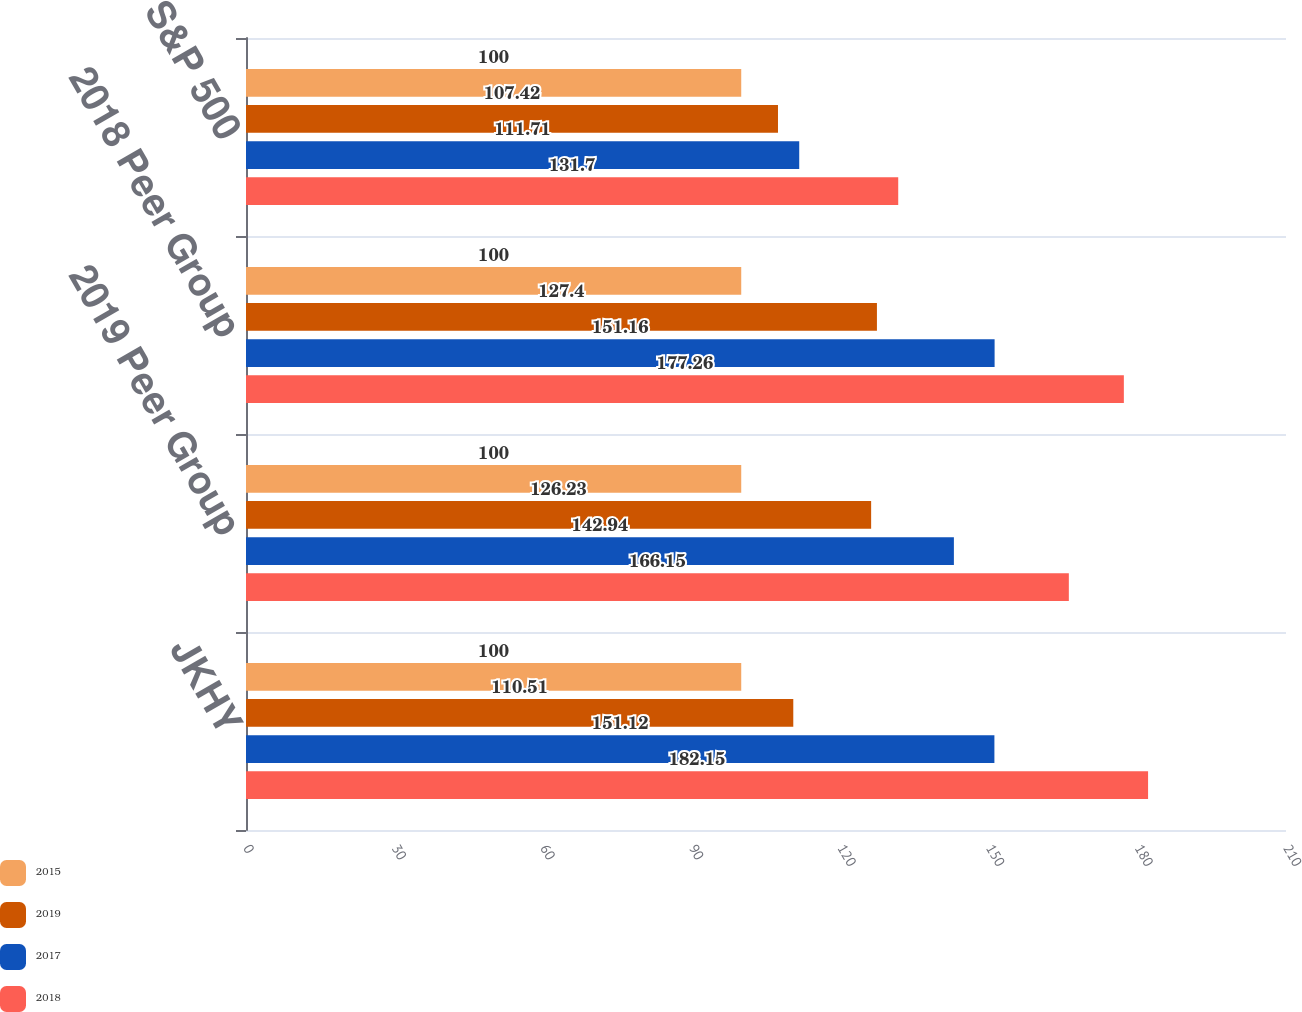Convert chart. <chart><loc_0><loc_0><loc_500><loc_500><stacked_bar_chart><ecel><fcel>JKHY<fcel>2019 Peer Group<fcel>2018 Peer Group<fcel>S&P 500<nl><fcel>2015<fcel>100<fcel>100<fcel>100<fcel>100<nl><fcel>2019<fcel>110.51<fcel>126.23<fcel>127.4<fcel>107.42<nl><fcel>2017<fcel>151.12<fcel>142.94<fcel>151.16<fcel>111.71<nl><fcel>2018<fcel>182.15<fcel>166.15<fcel>177.26<fcel>131.7<nl></chart> 